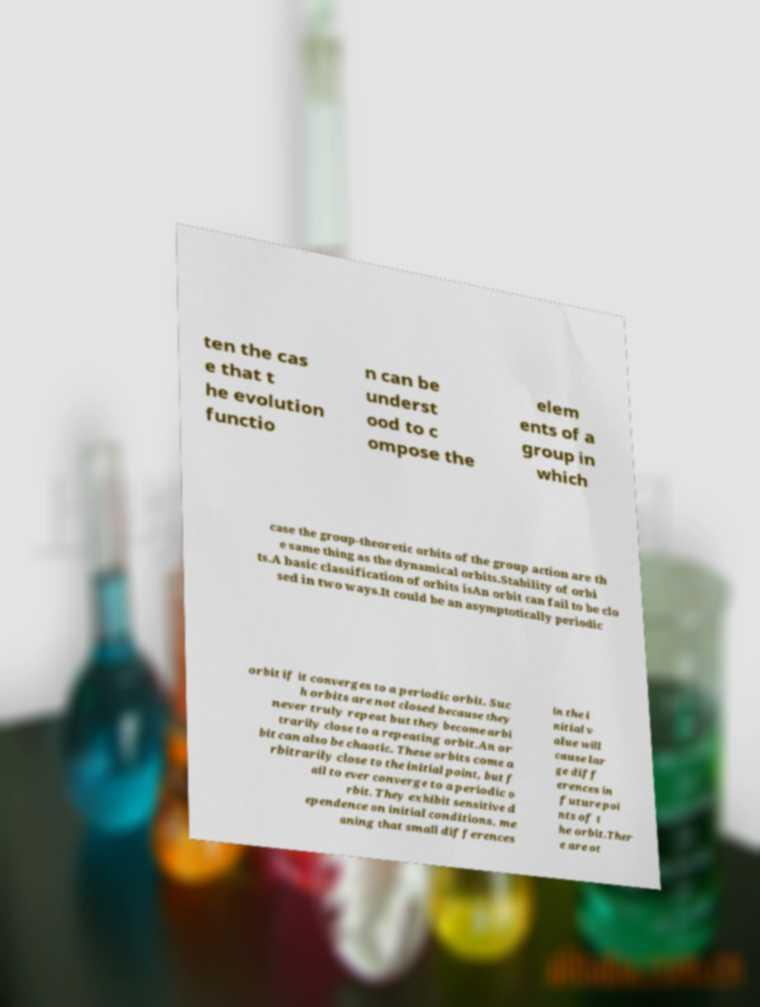Please read and relay the text visible in this image. What does it say? ten the cas e that t he evolution functio n can be underst ood to c ompose the elem ents of a group in which case the group-theoretic orbits of the group action are th e same thing as the dynamical orbits.Stability of orbi ts.A basic classification of orbits isAn orbit can fail to be clo sed in two ways.It could be an asymptotically periodic orbit if it converges to a periodic orbit. Suc h orbits are not closed because they never truly repeat but they become arbi trarily close to a repeating orbit.An or bit can also be chaotic. These orbits come a rbitrarily close to the initial point, but f ail to ever converge to a periodic o rbit. They exhibit sensitive d ependence on initial conditions, me aning that small differences in the i nitial v alue will cause lar ge diff erences in future poi nts of t he orbit.Ther e are ot 